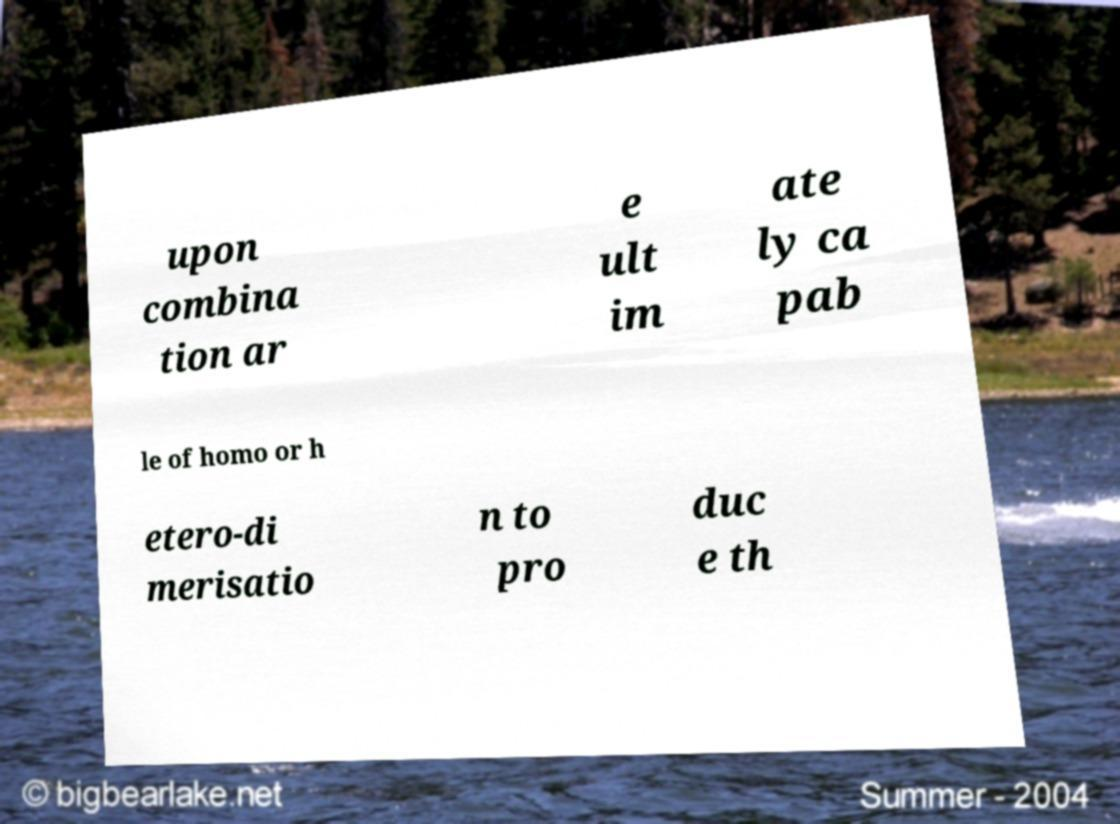For documentation purposes, I need the text within this image transcribed. Could you provide that? upon combina tion ar e ult im ate ly ca pab le of homo or h etero-di merisatio n to pro duc e th 